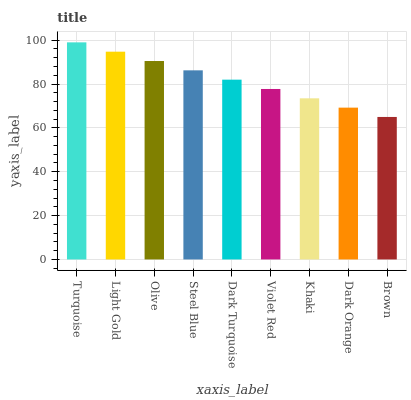Is Brown the minimum?
Answer yes or no. Yes. Is Turquoise the maximum?
Answer yes or no. Yes. Is Light Gold the minimum?
Answer yes or no. No. Is Light Gold the maximum?
Answer yes or no. No. Is Turquoise greater than Light Gold?
Answer yes or no. Yes. Is Light Gold less than Turquoise?
Answer yes or no. Yes. Is Light Gold greater than Turquoise?
Answer yes or no. No. Is Turquoise less than Light Gold?
Answer yes or no. No. Is Dark Turquoise the high median?
Answer yes or no. Yes. Is Dark Turquoise the low median?
Answer yes or no. Yes. Is Olive the high median?
Answer yes or no. No. Is Steel Blue the low median?
Answer yes or no. No. 